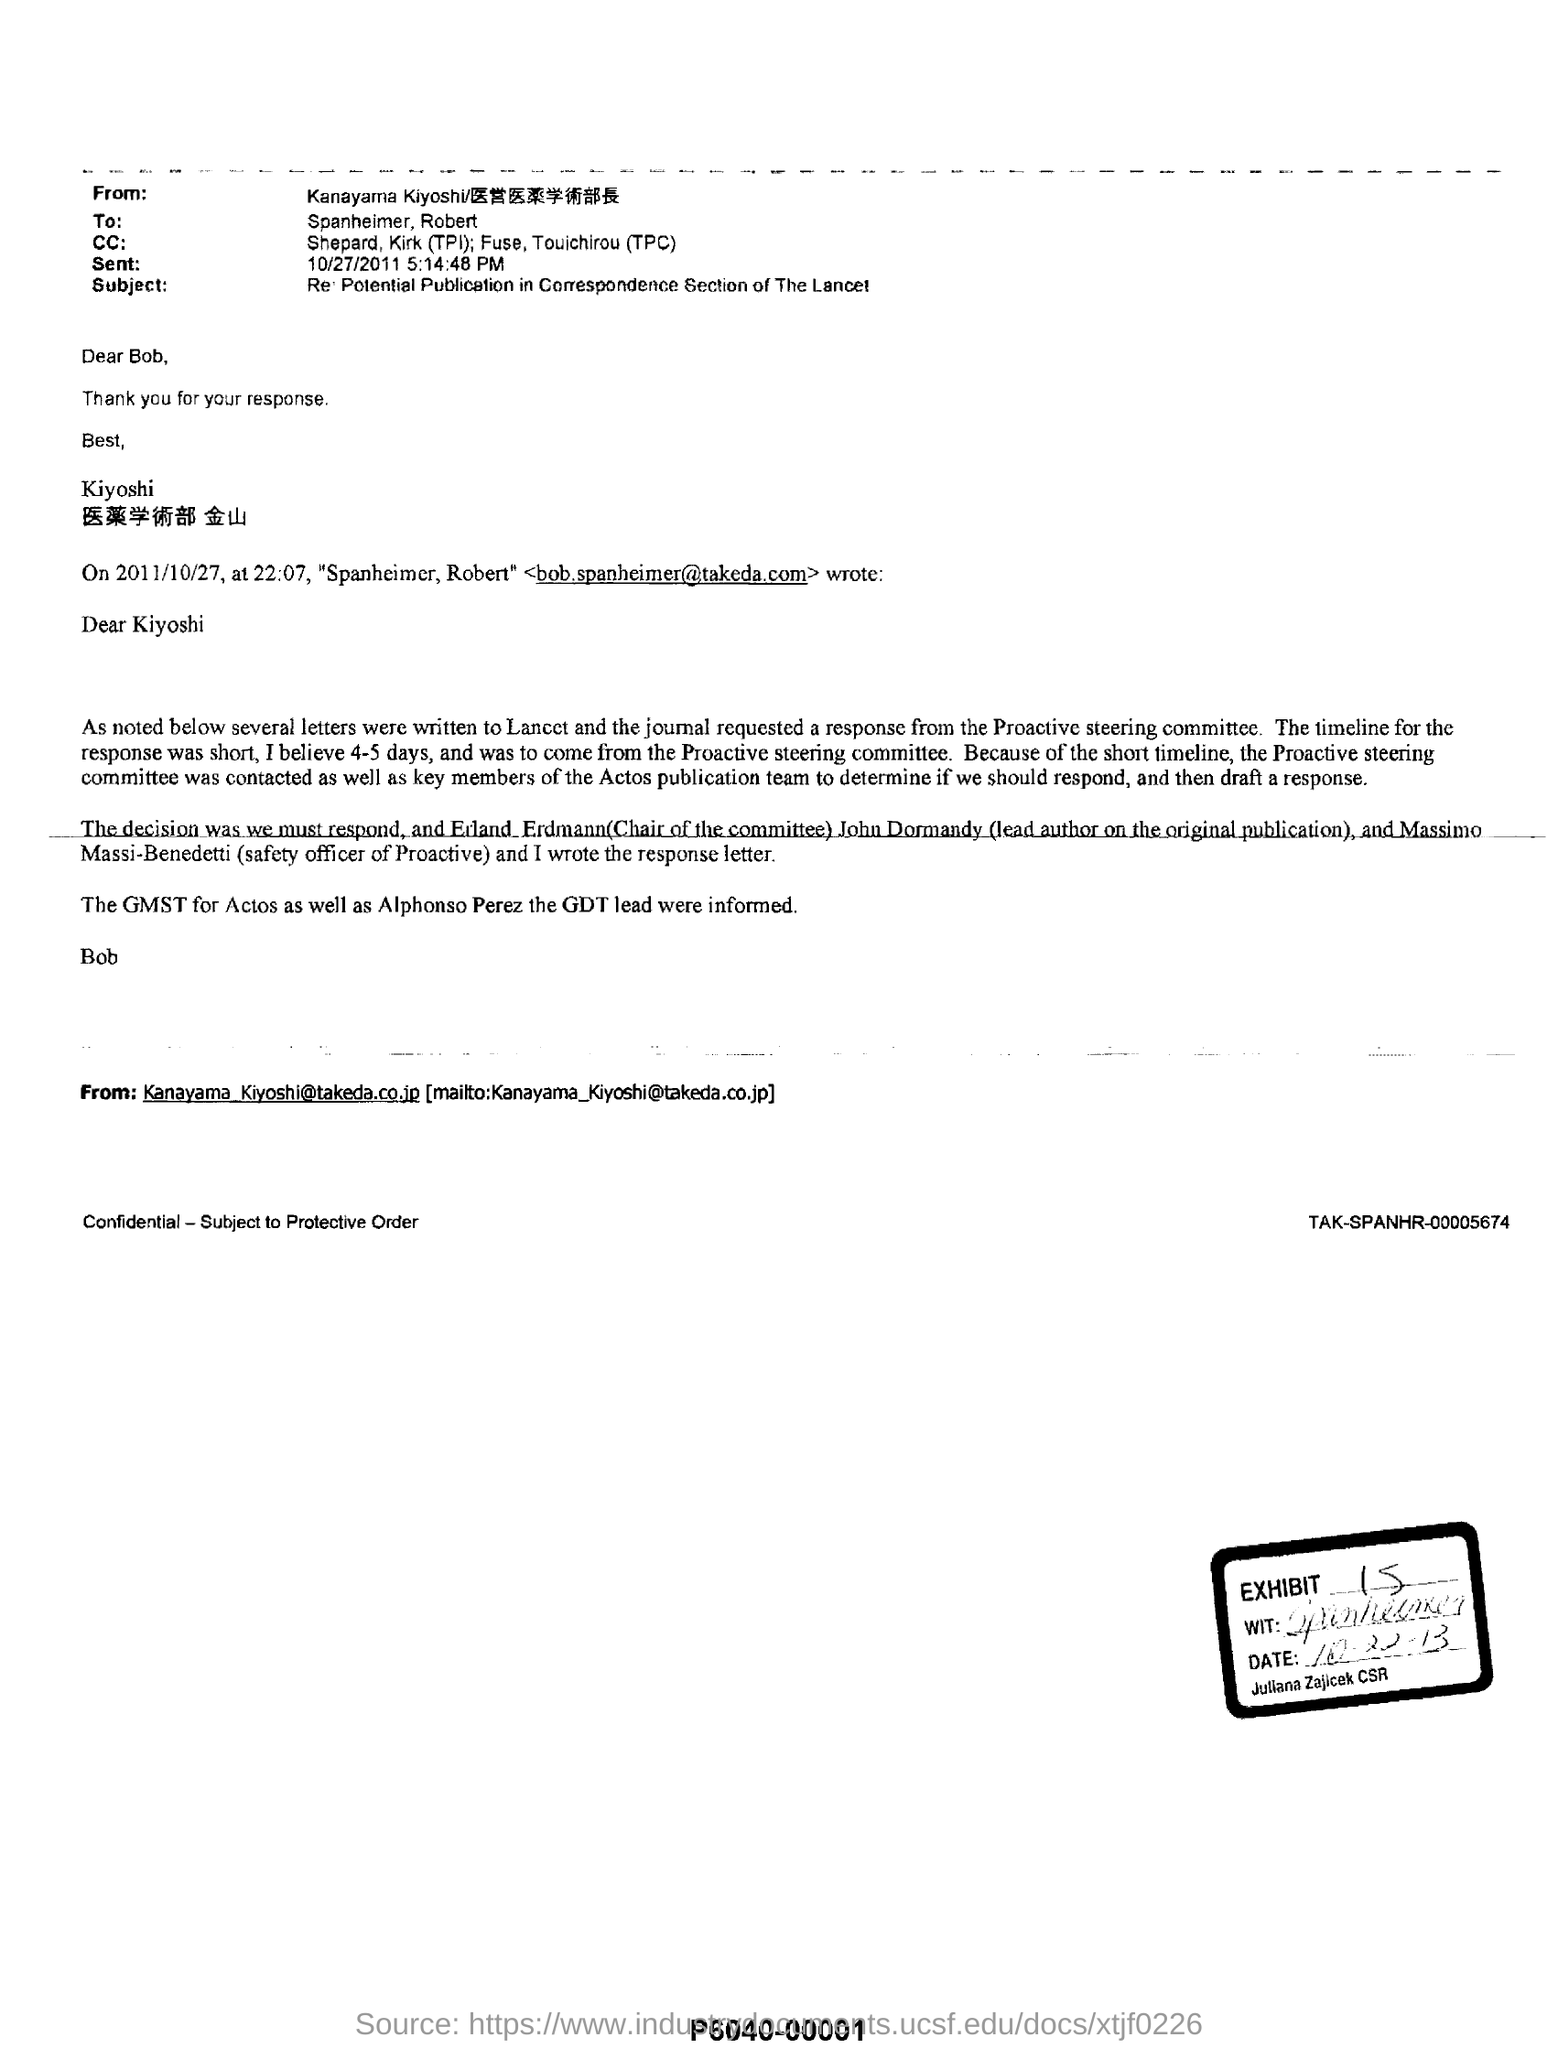Identify some key points in this picture. The email address of Kanayama Kiyoshi is [Kanayama\_Kiyoshi@takeda.co.jp](mailto:Kanayama_Kiyoshi@takeda.co.jp). The individuals named Shephard and Kirk (TPI) and Fuse, Touichirou (TPC) are on the CC list. The subject of this email is the possibility of publishing correspondence in the Correspondence section of The Lancet. 